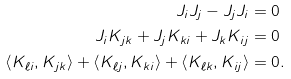<formula> <loc_0><loc_0><loc_500><loc_500>J _ { i } J _ { j } - J _ { j } J _ { i } & = 0 \\ J _ { i } K _ { j k } + J _ { j } K _ { k i } + J _ { k } K _ { i j } & = 0 \\ \left < K _ { \ell i } , K _ { j k } \right > + \left < K _ { \ell j } , K _ { k i } \right > + \left < K _ { \ell k } , K _ { i j } \right > & = 0 .</formula> 